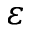<formula> <loc_0><loc_0><loc_500><loc_500>\varepsilon</formula> 